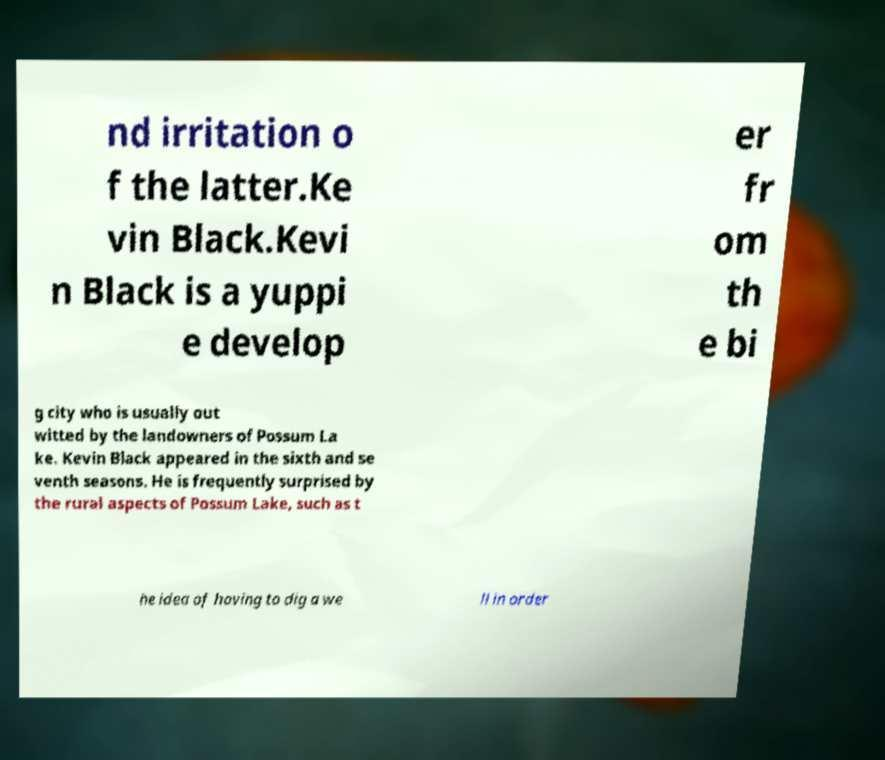Could you extract and type out the text from this image? nd irritation o f the latter.Ke vin Black.Kevi n Black is a yuppi e develop er fr om th e bi g city who is usually out witted by the landowners of Possum La ke. Kevin Black appeared in the sixth and se venth seasons. He is frequently surprised by the rural aspects of Possum Lake, such as t he idea of having to dig a we ll in order 